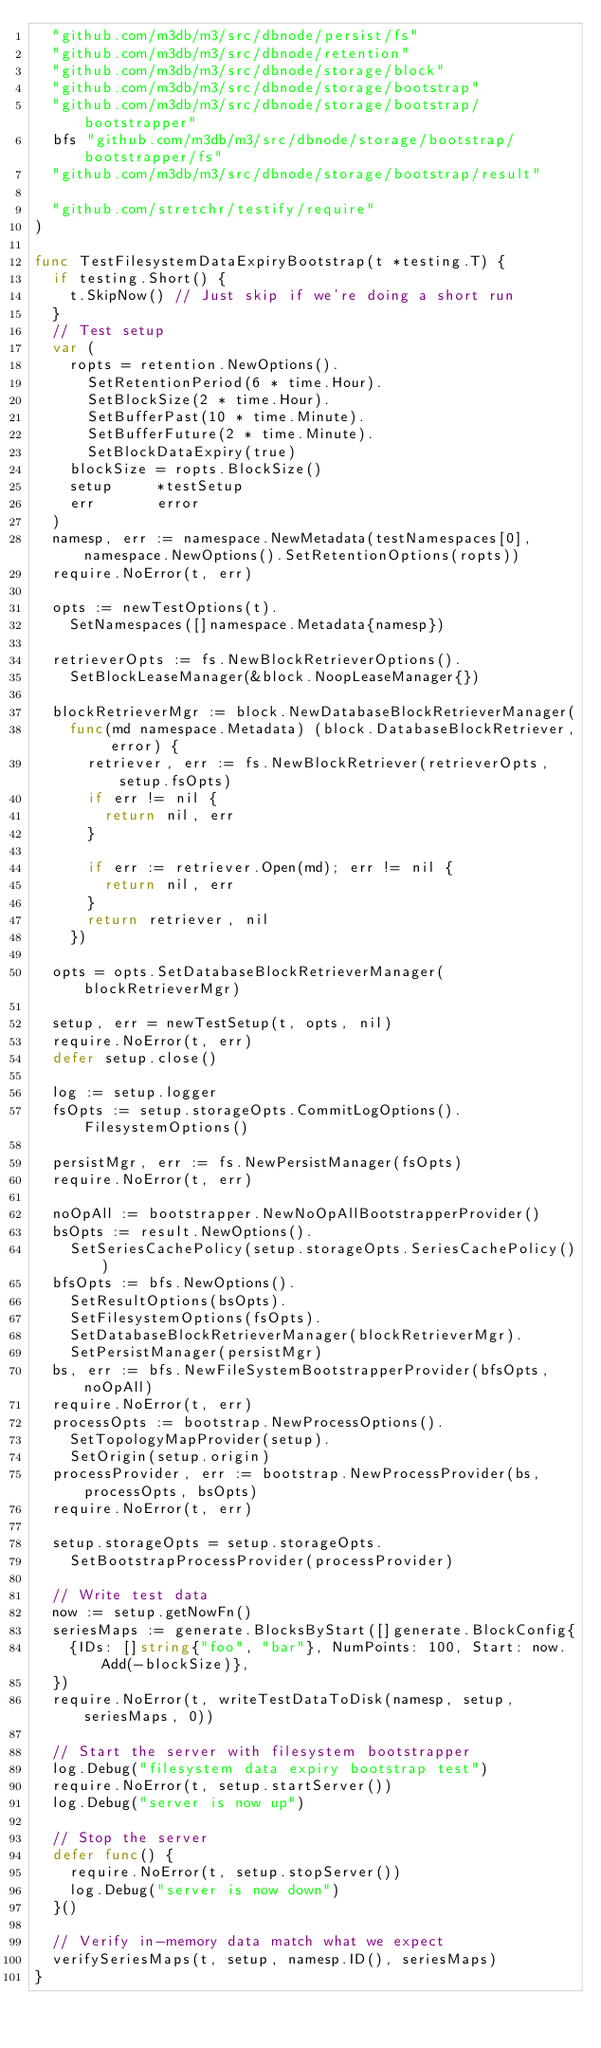<code> <loc_0><loc_0><loc_500><loc_500><_Go_>	"github.com/m3db/m3/src/dbnode/persist/fs"
	"github.com/m3db/m3/src/dbnode/retention"
	"github.com/m3db/m3/src/dbnode/storage/block"
	"github.com/m3db/m3/src/dbnode/storage/bootstrap"
	"github.com/m3db/m3/src/dbnode/storage/bootstrap/bootstrapper"
	bfs "github.com/m3db/m3/src/dbnode/storage/bootstrap/bootstrapper/fs"
	"github.com/m3db/m3/src/dbnode/storage/bootstrap/result"

	"github.com/stretchr/testify/require"
)

func TestFilesystemDataExpiryBootstrap(t *testing.T) {
	if testing.Short() {
		t.SkipNow() // Just skip if we're doing a short run
	}
	// Test setup
	var (
		ropts = retention.NewOptions().
			SetRetentionPeriod(6 * time.Hour).
			SetBlockSize(2 * time.Hour).
			SetBufferPast(10 * time.Minute).
			SetBufferFuture(2 * time.Minute).
			SetBlockDataExpiry(true)
		blockSize = ropts.BlockSize()
		setup     *testSetup
		err       error
	)
	namesp, err := namespace.NewMetadata(testNamespaces[0], namespace.NewOptions().SetRetentionOptions(ropts))
	require.NoError(t, err)

	opts := newTestOptions(t).
		SetNamespaces([]namespace.Metadata{namesp})

	retrieverOpts := fs.NewBlockRetrieverOptions().
		SetBlockLeaseManager(&block.NoopLeaseManager{})

	blockRetrieverMgr := block.NewDatabaseBlockRetrieverManager(
		func(md namespace.Metadata) (block.DatabaseBlockRetriever, error) {
			retriever, err := fs.NewBlockRetriever(retrieverOpts, setup.fsOpts)
			if err != nil {
				return nil, err
			}

			if err := retriever.Open(md); err != nil {
				return nil, err
			}
			return retriever, nil
		})

	opts = opts.SetDatabaseBlockRetrieverManager(blockRetrieverMgr)

	setup, err = newTestSetup(t, opts, nil)
	require.NoError(t, err)
	defer setup.close()

	log := setup.logger
	fsOpts := setup.storageOpts.CommitLogOptions().FilesystemOptions()

	persistMgr, err := fs.NewPersistManager(fsOpts)
	require.NoError(t, err)

	noOpAll := bootstrapper.NewNoOpAllBootstrapperProvider()
	bsOpts := result.NewOptions().
		SetSeriesCachePolicy(setup.storageOpts.SeriesCachePolicy())
	bfsOpts := bfs.NewOptions().
		SetResultOptions(bsOpts).
		SetFilesystemOptions(fsOpts).
		SetDatabaseBlockRetrieverManager(blockRetrieverMgr).
		SetPersistManager(persistMgr)
	bs, err := bfs.NewFileSystemBootstrapperProvider(bfsOpts, noOpAll)
	require.NoError(t, err)
	processOpts := bootstrap.NewProcessOptions().
		SetTopologyMapProvider(setup).
		SetOrigin(setup.origin)
	processProvider, err := bootstrap.NewProcessProvider(bs, processOpts, bsOpts)
	require.NoError(t, err)

	setup.storageOpts = setup.storageOpts.
		SetBootstrapProcessProvider(processProvider)

	// Write test data
	now := setup.getNowFn()
	seriesMaps := generate.BlocksByStart([]generate.BlockConfig{
		{IDs: []string{"foo", "bar"}, NumPoints: 100, Start: now.Add(-blockSize)},
	})
	require.NoError(t, writeTestDataToDisk(namesp, setup, seriesMaps, 0))

	// Start the server with filesystem bootstrapper
	log.Debug("filesystem data expiry bootstrap test")
	require.NoError(t, setup.startServer())
	log.Debug("server is now up")

	// Stop the server
	defer func() {
		require.NoError(t, setup.stopServer())
		log.Debug("server is now down")
	}()

	// Verify in-memory data match what we expect
	verifySeriesMaps(t, setup, namesp.ID(), seriesMaps)
}
</code> 